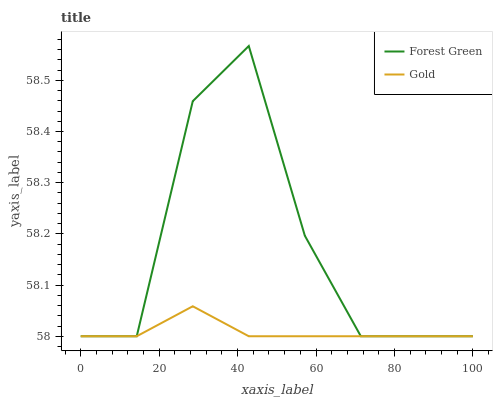Does Gold have the maximum area under the curve?
Answer yes or no. No. Is Gold the roughest?
Answer yes or no. No. Does Gold have the highest value?
Answer yes or no. No. 